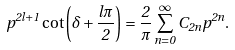Convert formula to latex. <formula><loc_0><loc_0><loc_500><loc_500>p ^ { 2 l + 1 } \cot \left ( \delta + \frac { l \pi } { 2 } \right ) = \frac { 2 } { \pi } \sum _ { n = 0 } ^ { \infty } C _ { 2 n } p ^ { 2 n } .</formula> 